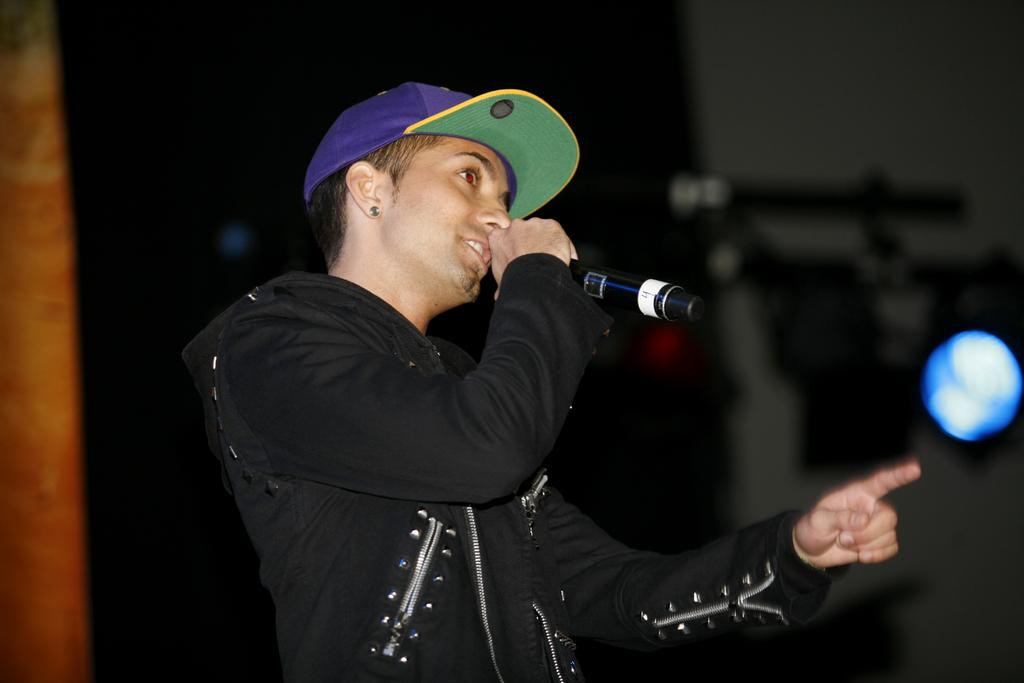What can be seen in the image? There is a person in the image. What is the person wearing? The person is wearing a cap. What is the person holding? The person is holding a microphone. What color is the light in the background? There is a blue light in the background. How would you describe the background? The background is blurry. How many goldfish are swimming in the background of the image? There are no goldfish present in the image; the background is blurry and features a blue light. 